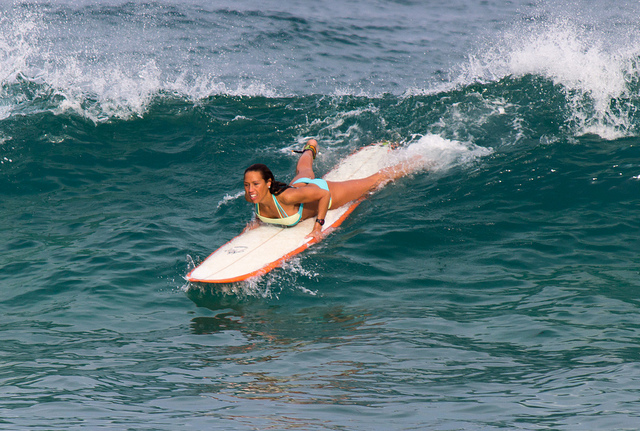<image>What color is in a circle on the surfboard? I am not sure about the color in the circle on the surfboard, it could be black, green, white, blue, gray or red. What color is in a circle on the surfboard? There is no color in a circle on the surfboard. 